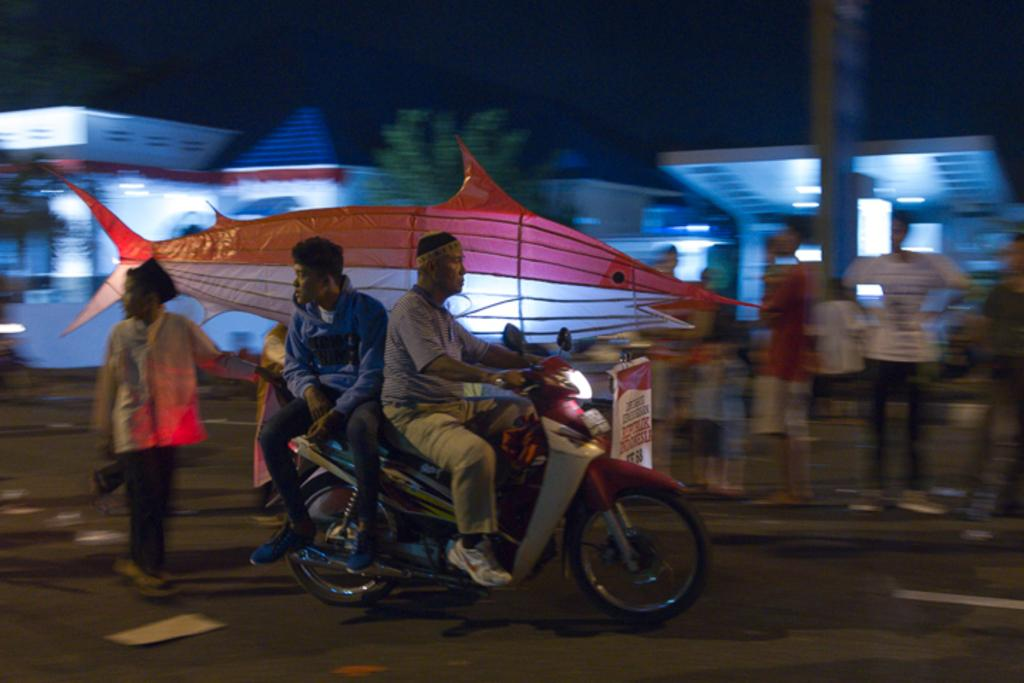How many people are on the motorcycle in the image? There are two men on the motorcycle in the image. What else can be seen on the road besides the motorcycle? There are people standing on the road in the image. What is the shape of the hoarding visible in the image? The hoarding has a fish-shaped design. How many houses can be seen in the image? There are two houses visible in the image. What type of vegetation is present in the image? There is a tree in the image. What type of rake is being used to collect the scent in the image? There is no rake or scent present in the image. Who is wearing the crown in the image? There is no crown or person wearing a crown in the image. 